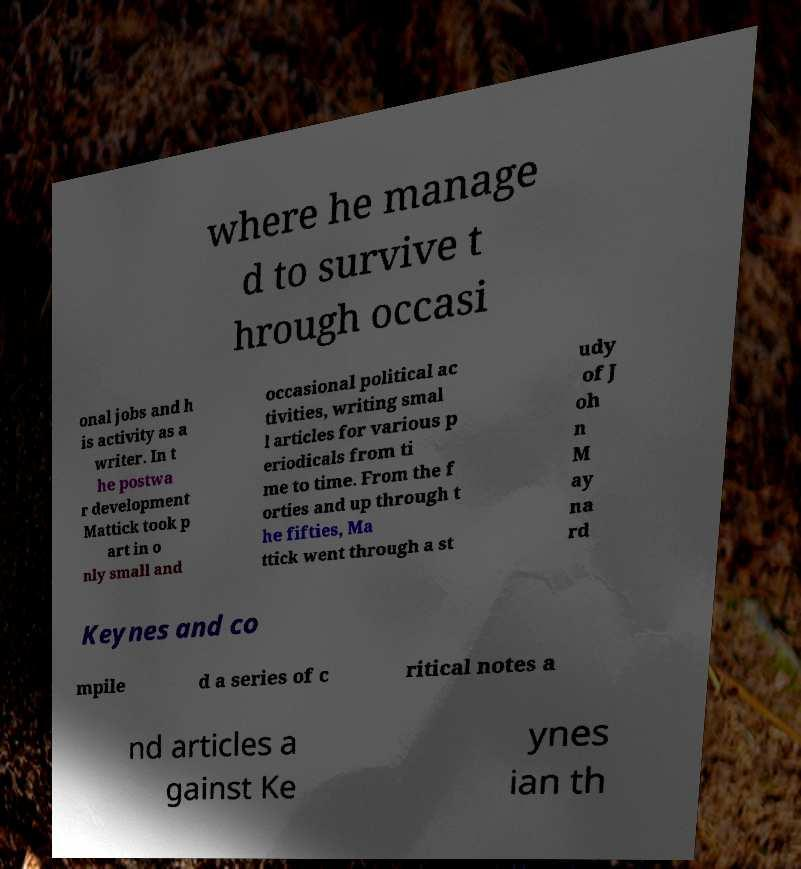What messages or text are displayed in this image? I need them in a readable, typed format. where he manage d to survive t hrough occasi onal jobs and h is activity as a writer. In t he postwa r development Mattick took p art in o nly small and occasional political ac tivities, writing smal l articles for various p eriodicals from ti me to time. From the f orties and up through t he fifties, Ma ttick went through a st udy of J oh n M ay na rd Keynes and co mpile d a series of c ritical notes a nd articles a gainst Ke ynes ian th 